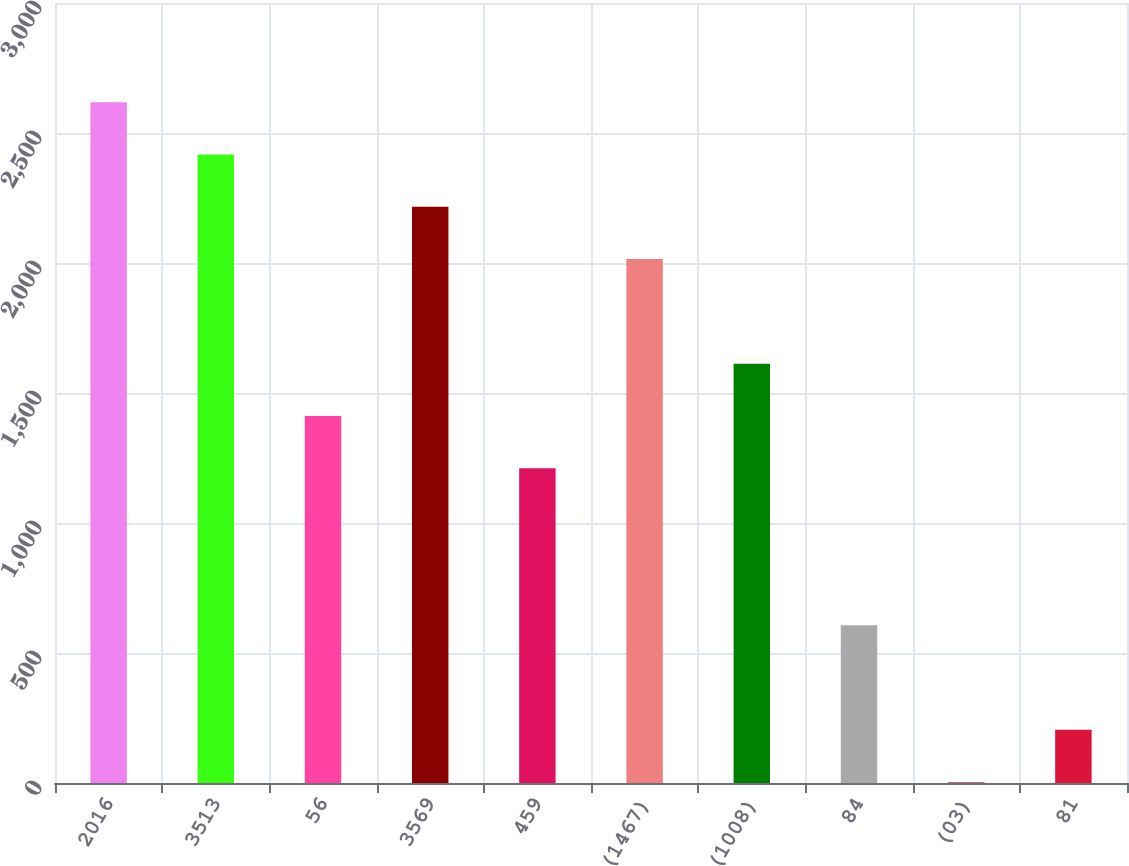<chart> <loc_0><loc_0><loc_500><loc_500><bar_chart><fcel>2016<fcel>3513<fcel>56<fcel>3569<fcel>459<fcel>(1467)<fcel>(1008)<fcel>84<fcel>(03)<fcel>81<nl><fcel>2618.51<fcel>2417.34<fcel>1411.49<fcel>2216.17<fcel>1210.32<fcel>2015<fcel>1612.66<fcel>606.81<fcel>3.3<fcel>204.47<nl></chart> 